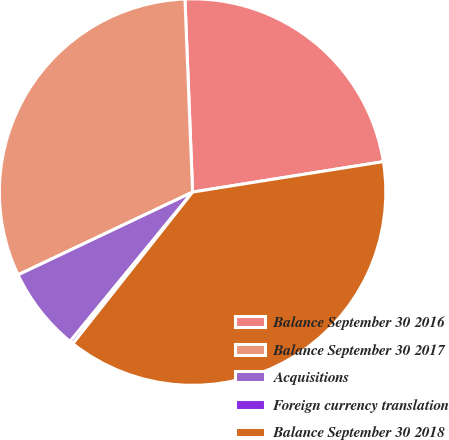<chart> <loc_0><loc_0><loc_500><loc_500><pie_chart><fcel>Balance September 30 2016<fcel>Balance September 30 2017<fcel>Acquisitions<fcel>Foreign currency translation<fcel>Balance September 30 2018<nl><fcel>23.11%<fcel>31.42%<fcel>7.02%<fcel>0.29%<fcel>38.16%<nl></chart> 